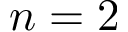Convert formula to latex. <formula><loc_0><loc_0><loc_500><loc_500>n = 2</formula> 